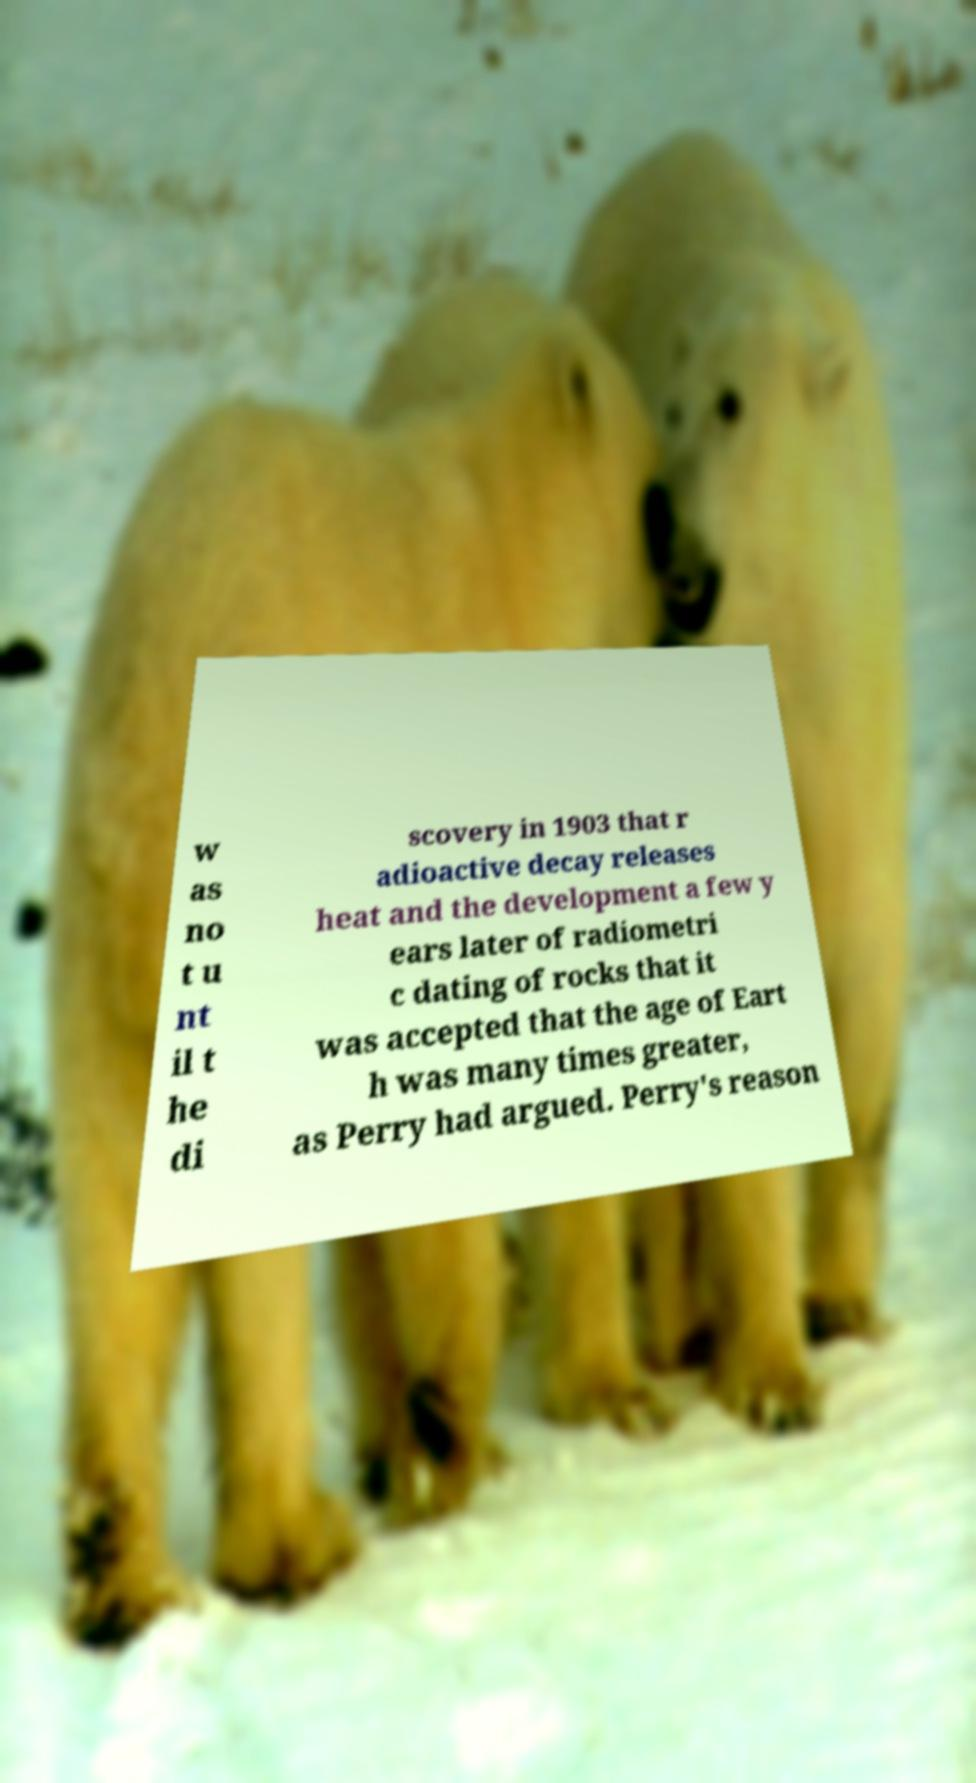What messages or text are displayed in this image? I need them in a readable, typed format. w as no t u nt il t he di scovery in 1903 that r adioactive decay releases heat and the development a few y ears later of radiometri c dating of rocks that it was accepted that the age of Eart h was many times greater, as Perry had argued. Perry's reason 